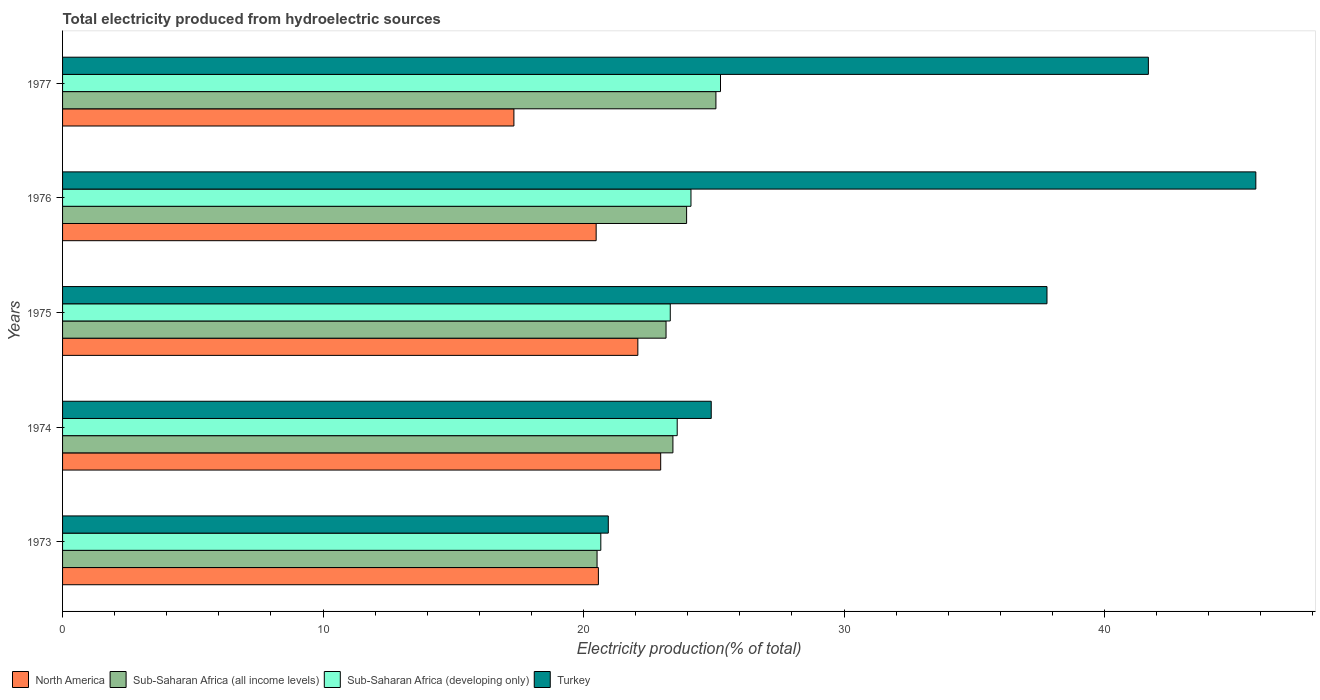How many different coloured bars are there?
Provide a short and direct response. 4. How many groups of bars are there?
Your response must be concise. 5. How many bars are there on the 3rd tick from the top?
Your answer should be compact. 4. How many bars are there on the 4th tick from the bottom?
Offer a very short reply. 4. In how many cases, is the number of bars for a given year not equal to the number of legend labels?
Make the answer very short. 0. What is the total electricity produced in North America in 1975?
Your response must be concise. 22.08. Across all years, what is the maximum total electricity produced in Sub-Saharan Africa (all income levels)?
Provide a short and direct response. 25.08. Across all years, what is the minimum total electricity produced in Turkey?
Offer a very short reply. 20.95. In which year was the total electricity produced in North America maximum?
Make the answer very short. 1974. In which year was the total electricity produced in North America minimum?
Keep it short and to the point. 1977. What is the total total electricity produced in Sub-Saharan Africa (developing only) in the graph?
Your answer should be compact. 116.97. What is the difference between the total electricity produced in Sub-Saharan Africa (all income levels) in 1973 and that in 1975?
Your response must be concise. -2.65. What is the difference between the total electricity produced in Turkey in 1973 and the total electricity produced in Sub-Saharan Africa (developing only) in 1974?
Your answer should be compact. -2.65. What is the average total electricity produced in Turkey per year?
Provide a short and direct response. 34.23. In the year 1977, what is the difference between the total electricity produced in Sub-Saharan Africa (all income levels) and total electricity produced in North America?
Provide a short and direct response. 7.76. In how many years, is the total electricity produced in North America greater than 16 %?
Offer a very short reply. 5. What is the ratio of the total electricity produced in Turkey in 1974 to that in 1976?
Offer a very short reply. 0.54. What is the difference between the highest and the second highest total electricity produced in Sub-Saharan Africa (developing only)?
Give a very brief answer. 1.13. What is the difference between the highest and the lowest total electricity produced in Turkey?
Offer a terse response. 24.86. In how many years, is the total electricity produced in Sub-Saharan Africa (all income levels) greater than the average total electricity produced in Sub-Saharan Africa (all income levels) taken over all years?
Give a very brief answer. 3. What does the 1st bar from the top in 1974 represents?
Give a very brief answer. Turkey. How many bars are there?
Provide a succinct answer. 20. How many years are there in the graph?
Your answer should be compact. 5. What is the difference between two consecutive major ticks on the X-axis?
Make the answer very short. 10. Are the values on the major ticks of X-axis written in scientific E-notation?
Make the answer very short. No. Does the graph contain any zero values?
Keep it short and to the point. No. How many legend labels are there?
Keep it short and to the point. 4. How are the legend labels stacked?
Offer a terse response. Horizontal. What is the title of the graph?
Ensure brevity in your answer.  Total electricity produced from hydroelectric sources. What is the label or title of the Y-axis?
Offer a terse response. Years. What is the Electricity production(% of total) in North America in 1973?
Provide a succinct answer. 20.57. What is the Electricity production(% of total) in Sub-Saharan Africa (all income levels) in 1973?
Offer a terse response. 20.52. What is the Electricity production(% of total) of Sub-Saharan Africa (developing only) in 1973?
Keep it short and to the point. 20.66. What is the Electricity production(% of total) of Turkey in 1973?
Ensure brevity in your answer.  20.95. What is the Electricity production(% of total) in North America in 1974?
Make the answer very short. 22.96. What is the Electricity production(% of total) of Sub-Saharan Africa (all income levels) in 1974?
Provide a short and direct response. 23.43. What is the Electricity production(% of total) of Sub-Saharan Africa (developing only) in 1974?
Your answer should be compact. 23.59. What is the Electricity production(% of total) of Turkey in 1974?
Your response must be concise. 24.9. What is the Electricity production(% of total) of North America in 1975?
Offer a very short reply. 22.08. What is the Electricity production(% of total) in Sub-Saharan Africa (all income levels) in 1975?
Provide a succinct answer. 23.17. What is the Electricity production(% of total) of Sub-Saharan Africa (developing only) in 1975?
Offer a terse response. 23.33. What is the Electricity production(% of total) of Turkey in 1975?
Offer a very short reply. 37.79. What is the Electricity production(% of total) of North America in 1976?
Keep it short and to the point. 20.48. What is the Electricity production(% of total) in Sub-Saharan Africa (all income levels) in 1976?
Offer a terse response. 23.96. What is the Electricity production(% of total) in Sub-Saharan Africa (developing only) in 1976?
Your answer should be compact. 24.12. What is the Electricity production(% of total) in Turkey in 1976?
Your answer should be very brief. 45.81. What is the Electricity production(% of total) in North America in 1977?
Your answer should be very brief. 17.33. What is the Electricity production(% of total) of Sub-Saharan Africa (all income levels) in 1977?
Ensure brevity in your answer.  25.08. What is the Electricity production(% of total) of Sub-Saharan Africa (developing only) in 1977?
Make the answer very short. 25.26. What is the Electricity production(% of total) of Turkey in 1977?
Keep it short and to the point. 41.68. Across all years, what is the maximum Electricity production(% of total) of North America?
Give a very brief answer. 22.96. Across all years, what is the maximum Electricity production(% of total) in Sub-Saharan Africa (all income levels)?
Your response must be concise. 25.08. Across all years, what is the maximum Electricity production(% of total) of Sub-Saharan Africa (developing only)?
Give a very brief answer. 25.26. Across all years, what is the maximum Electricity production(% of total) in Turkey?
Ensure brevity in your answer.  45.81. Across all years, what is the minimum Electricity production(% of total) in North America?
Offer a terse response. 17.33. Across all years, what is the minimum Electricity production(% of total) in Sub-Saharan Africa (all income levels)?
Provide a succinct answer. 20.52. Across all years, what is the minimum Electricity production(% of total) of Sub-Saharan Africa (developing only)?
Your answer should be compact. 20.66. Across all years, what is the minimum Electricity production(% of total) of Turkey?
Offer a terse response. 20.95. What is the total Electricity production(% of total) of North America in the graph?
Keep it short and to the point. 103.42. What is the total Electricity production(% of total) in Sub-Saharan Africa (all income levels) in the graph?
Provide a short and direct response. 116.15. What is the total Electricity production(% of total) of Sub-Saharan Africa (developing only) in the graph?
Offer a terse response. 116.97. What is the total Electricity production(% of total) in Turkey in the graph?
Offer a very short reply. 171.13. What is the difference between the Electricity production(% of total) in North America in 1973 and that in 1974?
Ensure brevity in your answer.  -2.39. What is the difference between the Electricity production(% of total) in Sub-Saharan Africa (all income levels) in 1973 and that in 1974?
Ensure brevity in your answer.  -2.91. What is the difference between the Electricity production(% of total) in Sub-Saharan Africa (developing only) in 1973 and that in 1974?
Your response must be concise. -2.93. What is the difference between the Electricity production(% of total) in Turkey in 1973 and that in 1974?
Make the answer very short. -3.95. What is the difference between the Electricity production(% of total) in North America in 1973 and that in 1975?
Offer a very short reply. -1.51. What is the difference between the Electricity production(% of total) of Sub-Saharan Africa (all income levels) in 1973 and that in 1975?
Make the answer very short. -2.65. What is the difference between the Electricity production(% of total) in Sub-Saharan Africa (developing only) in 1973 and that in 1975?
Keep it short and to the point. -2.67. What is the difference between the Electricity production(% of total) of Turkey in 1973 and that in 1975?
Offer a terse response. -16.84. What is the difference between the Electricity production(% of total) in North America in 1973 and that in 1976?
Offer a terse response. 0.09. What is the difference between the Electricity production(% of total) in Sub-Saharan Africa (all income levels) in 1973 and that in 1976?
Your answer should be compact. -3.44. What is the difference between the Electricity production(% of total) in Sub-Saharan Africa (developing only) in 1973 and that in 1976?
Offer a terse response. -3.46. What is the difference between the Electricity production(% of total) of Turkey in 1973 and that in 1976?
Provide a short and direct response. -24.86. What is the difference between the Electricity production(% of total) of North America in 1973 and that in 1977?
Offer a terse response. 3.24. What is the difference between the Electricity production(% of total) of Sub-Saharan Africa (all income levels) in 1973 and that in 1977?
Your answer should be very brief. -4.56. What is the difference between the Electricity production(% of total) in Sub-Saharan Africa (developing only) in 1973 and that in 1977?
Offer a very short reply. -4.59. What is the difference between the Electricity production(% of total) in Turkey in 1973 and that in 1977?
Provide a short and direct response. -20.73. What is the difference between the Electricity production(% of total) of North America in 1974 and that in 1975?
Ensure brevity in your answer.  0.88. What is the difference between the Electricity production(% of total) in Sub-Saharan Africa (all income levels) in 1974 and that in 1975?
Keep it short and to the point. 0.26. What is the difference between the Electricity production(% of total) in Sub-Saharan Africa (developing only) in 1974 and that in 1975?
Your answer should be very brief. 0.27. What is the difference between the Electricity production(% of total) in Turkey in 1974 and that in 1975?
Keep it short and to the point. -12.89. What is the difference between the Electricity production(% of total) in North America in 1974 and that in 1976?
Your answer should be compact. 2.48. What is the difference between the Electricity production(% of total) of Sub-Saharan Africa (all income levels) in 1974 and that in 1976?
Keep it short and to the point. -0.53. What is the difference between the Electricity production(% of total) of Sub-Saharan Africa (developing only) in 1974 and that in 1976?
Offer a very short reply. -0.53. What is the difference between the Electricity production(% of total) of Turkey in 1974 and that in 1976?
Ensure brevity in your answer.  -20.91. What is the difference between the Electricity production(% of total) of North America in 1974 and that in 1977?
Offer a very short reply. 5.63. What is the difference between the Electricity production(% of total) of Sub-Saharan Africa (all income levels) in 1974 and that in 1977?
Offer a very short reply. -1.65. What is the difference between the Electricity production(% of total) of Sub-Saharan Africa (developing only) in 1974 and that in 1977?
Offer a very short reply. -1.66. What is the difference between the Electricity production(% of total) of Turkey in 1974 and that in 1977?
Provide a short and direct response. -16.78. What is the difference between the Electricity production(% of total) in North America in 1975 and that in 1976?
Make the answer very short. 1.6. What is the difference between the Electricity production(% of total) of Sub-Saharan Africa (all income levels) in 1975 and that in 1976?
Ensure brevity in your answer.  -0.79. What is the difference between the Electricity production(% of total) in Sub-Saharan Africa (developing only) in 1975 and that in 1976?
Offer a terse response. -0.79. What is the difference between the Electricity production(% of total) of Turkey in 1975 and that in 1976?
Offer a terse response. -8.02. What is the difference between the Electricity production(% of total) of North America in 1975 and that in 1977?
Provide a succinct answer. 4.76. What is the difference between the Electricity production(% of total) in Sub-Saharan Africa (all income levels) in 1975 and that in 1977?
Give a very brief answer. -1.91. What is the difference between the Electricity production(% of total) in Sub-Saharan Africa (developing only) in 1975 and that in 1977?
Provide a short and direct response. -1.93. What is the difference between the Electricity production(% of total) in Turkey in 1975 and that in 1977?
Your answer should be very brief. -3.89. What is the difference between the Electricity production(% of total) in North America in 1976 and that in 1977?
Give a very brief answer. 3.16. What is the difference between the Electricity production(% of total) of Sub-Saharan Africa (all income levels) in 1976 and that in 1977?
Your response must be concise. -1.13. What is the difference between the Electricity production(% of total) of Sub-Saharan Africa (developing only) in 1976 and that in 1977?
Provide a succinct answer. -1.13. What is the difference between the Electricity production(% of total) in Turkey in 1976 and that in 1977?
Your answer should be very brief. 4.13. What is the difference between the Electricity production(% of total) in North America in 1973 and the Electricity production(% of total) in Sub-Saharan Africa (all income levels) in 1974?
Keep it short and to the point. -2.86. What is the difference between the Electricity production(% of total) of North America in 1973 and the Electricity production(% of total) of Sub-Saharan Africa (developing only) in 1974?
Ensure brevity in your answer.  -3.03. What is the difference between the Electricity production(% of total) in North America in 1973 and the Electricity production(% of total) in Turkey in 1974?
Provide a short and direct response. -4.33. What is the difference between the Electricity production(% of total) of Sub-Saharan Africa (all income levels) in 1973 and the Electricity production(% of total) of Sub-Saharan Africa (developing only) in 1974?
Offer a terse response. -3.08. What is the difference between the Electricity production(% of total) of Sub-Saharan Africa (all income levels) in 1973 and the Electricity production(% of total) of Turkey in 1974?
Ensure brevity in your answer.  -4.38. What is the difference between the Electricity production(% of total) of Sub-Saharan Africa (developing only) in 1973 and the Electricity production(% of total) of Turkey in 1974?
Keep it short and to the point. -4.24. What is the difference between the Electricity production(% of total) of North America in 1973 and the Electricity production(% of total) of Sub-Saharan Africa (all income levels) in 1975?
Offer a very short reply. -2.6. What is the difference between the Electricity production(% of total) of North America in 1973 and the Electricity production(% of total) of Sub-Saharan Africa (developing only) in 1975?
Keep it short and to the point. -2.76. What is the difference between the Electricity production(% of total) of North America in 1973 and the Electricity production(% of total) of Turkey in 1975?
Ensure brevity in your answer.  -17.22. What is the difference between the Electricity production(% of total) of Sub-Saharan Africa (all income levels) in 1973 and the Electricity production(% of total) of Sub-Saharan Africa (developing only) in 1975?
Provide a succinct answer. -2.81. What is the difference between the Electricity production(% of total) in Sub-Saharan Africa (all income levels) in 1973 and the Electricity production(% of total) in Turkey in 1975?
Offer a terse response. -17.27. What is the difference between the Electricity production(% of total) of Sub-Saharan Africa (developing only) in 1973 and the Electricity production(% of total) of Turkey in 1975?
Your response must be concise. -17.13. What is the difference between the Electricity production(% of total) of North America in 1973 and the Electricity production(% of total) of Sub-Saharan Africa (all income levels) in 1976?
Ensure brevity in your answer.  -3.39. What is the difference between the Electricity production(% of total) of North America in 1973 and the Electricity production(% of total) of Sub-Saharan Africa (developing only) in 1976?
Give a very brief answer. -3.55. What is the difference between the Electricity production(% of total) in North America in 1973 and the Electricity production(% of total) in Turkey in 1976?
Offer a terse response. -25.24. What is the difference between the Electricity production(% of total) of Sub-Saharan Africa (all income levels) in 1973 and the Electricity production(% of total) of Sub-Saharan Africa (developing only) in 1976?
Your answer should be very brief. -3.6. What is the difference between the Electricity production(% of total) of Sub-Saharan Africa (all income levels) in 1973 and the Electricity production(% of total) of Turkey in 1976?
Provide a short and direct response. -25.29. What is the difference between the Electricity production(% of total) of Sub-Saharan Africa (developing only) in 1973 and the Electricity production(% of total) of Turkey in 1976?
Make the answer very short. -25.15. What is the difference between the Electricity production(% of total) of North America in 1973 and the Electricity production(% of total) of Sub-Saharan Africa (all income levels) in 1977?
Keep it short and to the point. -4.51. What is the difference between the Electricity production(% of total) in North America in 1973 and the Electricity production(% of total) in Sub-Saharan Africa (developing only) in 1977?
Your response must be concise. -4.69. What is the difference between the Electricity production(% of total) of North America in 1973 and the Electricity production(% of total) of Turkey in 1977?
Provide a short and direct response. -21.11. What is the difference between the Electricity production(% of total) in Sub-Saharan Africa (all income levels) in 1973 and the Electricity production(% of total) in Sub-Saharan Africa (developing only) in 1977?
Your answer should be compact. -4.74. What is the difference between the Electricity production(% of total) in Sub-Saharan Africa (all income levels) in 1973 and the Electricity production(% of total) in Turkey in 1977?
Provide a short and direct response. -21.16. What is the difference between the Electricity production(% of total) in Sub-Saharan Africa (developing only) in 1973 and the Electricity production(% of total) in Turkey in 1977?
Provide a short and direct response. -21.02. What is the difference between the Electricity production(% of total) of North America in 1974 and the Electricity production(% of total) of Sub-Saharan Africa (all income levels) in 1975?
Provide a short and direct response. -0.21. What is the difference between the Electricity production(% of total) in North America in 1974 and the Electricity production(% of total) in Sub-Saharan Africa (developing only) in 1975?
Give a very brief answer. -0.37. What is the difference between the Electricity production(% of total) of North America in 1974 and the Electricity production(% of total) of Turkey in 1975?
Keep it short and to the point. -14.83. What is the difference between the Electricity production(% of total) in Sub-Saharan Africa (all income levels) in 1974 and the Electricity production(% of total) in Sub-Saharan Africa (developing only) in 1975?
Give a very brief answer. 0.1. What is the difference between the Electricity production(% of total) in Sub-Saharan Africa (all income levels) in 1974 and the Electricity production(% of total) in Turkey in 1975?
Ensure brevity in your answer.  -14.36. What is the difference between the Electricity production(% of total) of Sub-Saharan Africa (developing only) in 1974 and the Electricity production(% of total) of Turkey in 1975?
Ensure brevity in your answer.  -14.2. What is the difference between the Electricity production(% of total) of North America in 1974 and the Electricity production(% of total) of Sub-Saharan Africa (all income levels) in 1976?
Your response must be concise. -0.99. What is the difference between the Electricity production(% of total) of North America in 1974 and the Electricity production(% of total) of Sub-Saharan Africa (developing only) in 1976?
Give a very brief answer. -1.16. What is the difference between the Electricity production(% of total) of North America in 1974 and the Electricity production(% of total) of Turkey in 1976?
Provide a succinct answer. -22.85. What is the difference between the Electricity production(% of total) of Sub-Saharan Africa (all income levels) in 1974 and the Electricity production(% of total) of Sub-Saharan Africa (developing only) in 1976?
Ensure brevity in your answer.  -0.69. What is the difference between the Electricity production(% of total) in Sub-Saharan Africa (all income levels) in 1974 and the Electricity production(% of total) in Turkey in 1976?
Offer a terse response. -22.38. What is the difference between the Electricity production(% of total) of Sub-Saharan Africa (developing only) in 1974 and the Electricity production(% of total) of Turkey in 1976?
Provide a short and direct response. -22.21. What is the difference between the Electricity production(% of total) in North America in 1974 and the Electricity production(% of total) in Sub-Saharan Africa (all income levels) in 1977?
Your response must be concise. -2.12. What is the difference between the Electricity production(% of total) in North America in 1974 and the Electricity production(% of total) in Sub-Saharan Africa (developing only) in 1977?
Provide a succinct answer. -2.3. What is the difference between the Electricity production(% of total) of North America in 1974 and the Electricity production(% of total) of Turkey in 1977?
Ensure brevity in your answer.  -18.72. What is the difference between the Electricity production(% of total) in Sub-Saharan Africa (all income levels) in 1974 and the Electricity production(% of total) in Sub-Saharan Africa (developing only) in 1977?
Offer a terse response. -1.83. What is the difference between the Electricity production(% of total) in Sub-Saharan Africa (all income levels) in 1974 and the Electricity production(% of total) in Turkey in 1977?
Your answer should be compact. -18.25. What is the difference between the Electricity production(% of total) of Sub-Saharan Africa (developing only) in 1974 and the Electricity production(% of total) of Turkey in 1977?
Your answer should be compact. -18.09. What is the difference between the Electricity production(% of total) of North America in 1975 and the Electricity production(% of total) of Sub-Saharan Africa (all income levels) in 1976?
Your response must be concise. -1.87. What is the difference between the Electricity production(% of total) of North America in 1975 and the Electricity production(% of total) of Sub-Saharan Africa (developing only) in 1976?
Ensure brevity in your answer.  -2.04. What is the difference between the Electricity production(% of total) in North America in 1975 and the Electricity production(% of total) in Turkey in 1976?
Offer a very short reply. -23.72. What is the difference between the Electricity production(% of total) of Sub-Saharan Africa (all income levels) in 1975 and the Electricity production(% of total) of Sub-Saharan Africa (developing only) in 1976?
Provide a succinct answer. -0.96. What is the difference between the Electricity production(% of total) of Sub-Saharan Africa (all income levels) in 1975 and the Electricity production(% of total) of Turkey in 1976?
Give a very brief answer. -22.64. What is the difference between the Electricity production(% of total) of Sub-Saharan Africa (developing only) in 1975 and the Electricity production(% of total) of Turkey in 1976?
Offer a terse response. -22.48. What is the difference between the Electricity production(% of total) in North America in 1975 and the Electricity production(% of total) in Sub-Saharan Africa (all income levels) in 1977?
Your answer should be very brief. -3. What is the difference between the Electricity production(% of total) in North America in 1975 and the Electricity production(% of total) in Sub-Saharan Africa (developing only) in 1977?
Ensure brevity in your answer.  -3.17. What is the difference between the Electricity production(% of total) in North America in 1975 and the Electricity production(% of total) in Turkey in 1977?
Make the answer very short. -19.6. What is the difference between the Electricity production(% of total) of Sub-Saharan Africa (all income levels) in 1975 and the Electricity production(% of total) of Sub-Saharan Africa (developing only) in 1977?
Make the answer very short. -2.09. What is the difference between the Electricity production(% of total) of Sub-Saharan Africa (all income levels) in 1975 and the Electricity production(% of total) of Turkey in 1977?
Your response must be concise. -18.52. What is the difference between the Electricity production(% of total) of Sub-Saharan Africa (developing only) in 1975 and the Electricity production(% of total) of Turkey in 1977?
Offer a terse response. -18.35. What is the difference between the Electricity production(% of total) of North America in 1976 and the Electricity production(% of total) of Sub-Saharan Africa (all income levels) in 1977?
Offer a very short reply. -4.6. What is the difference between the Electricity production(% of total) in North America in 1976 and the Electricity production(% of total) in Sub-Saharan Africa (developing only) in 1977?
Offer a very short reply. -4.77. What is the difference between the Electricity production(% of total) in North America in 1976 and the Electricity production(% of total) in Turkey in 1977?
Your response must be concise. -21.2. What is the difference between the Electricity production(% of total) in Sub-Saharan Africa (all income levels) in 1976 and the Electricity production(% of total) in Sub-Saharan Africa (developing only) in 1977?
Provide a succinct answer. -1.3. What is the difference between the Electricity production(% of total) of Sub-Saharan Africa (all income levels) in 1976 and the Electricity production(% of total) of Turkey in 1977?
Give a very brief answer. -17.73. What is the difference between the Electricity production(% of total) in Sub-Saharan Africa (developing only) in 1976 and the Electricity production(% of total) in Turkey in 1977?
Ensure brevity in your answer.  -17.56. What is the average Electricity production(% of total) of North America per year?
Your answer should be compact. 20.68. What is the average Electricity production(% of total) of Sub-Saharan Africa (all income levels) per year?
Provide a short and direct response. 23.23. What is the average Electricity production(% of total) of Sub-Saharan Africa (developing only) per year?
Offer a very short reply. 23.39. What is the average Electricity production(% of total) in Turkey per year?
Offer a very short reply. 34.23. In the year 1973, what is the difference between the Electricity production(% of total) in North America and Electricity production(% of total) in Sub-Saharan Africa (all income levels)?
Provide a succinct answer. 0.05. In the year 1973, what is the difference between the Electricity production(% of total) of North America and Electricity production(% of total) of Sub-Saharan Africa (developing only)?
Your answer should be very brief. -0.09. In the year 1973, what is the difference between the Electricity production(% of total) in North America and Electricity production(% of total) in Turkey?
Provide a succinct answer. -0.38. In the year 1973, what is the difference between the Electricity production(% of total) in Sub-Saharan Africa (all income levels) and Electricity production(% of total) in Sub-Saharan Africa (developing only)?
Your answer should be compact. -0.14. In the year 1973, what is the difference between the Electricity production(% of total) in Sub-Saharan Africa (all income levels) and Electricity production(% of total) in Turkey?
Offer a very short reply. -0.43. In the year 1973, what is the difference between the Electricity production(% of total) of Sub-Saharan Africa (developing only) and Electricity production(% of total) of Turkey?
Provide a succinct answer. -0.29. In the year 1974, what is the difference between the Electricity production(% of total) in North America and Electricity production(% of total) in Sub-Saharan Africa (all income levels)?
Ensure brevity in your answer.  -0.47. In the year 1974, what is the difference between the Electricity production(% of total) in North America and Electricity production(% of total) in Sub-Saharan Africa (developing only)?
Ensure brevity in your answer.  -0.63. In the year 1974, what is the difference between the Electricity production(% of total) in North America and Electricity production(% of total) in Turkey?
Your answer should be compact. -1.94. In the year 1974, what is the difference between the Electricity production(% of total) in Sub-Saharan Africa (all income levels) and Electricity production(% of total) in Sub-Saharan Africa (developing only)?
Your answer should be compact. -0.16. In the year 1974, what is the difference between the Electricity production(% of total) in Sub-Saharan Africa (all income levels) and Electricity production(% of total) in Turkey?
Ensure brevity in your answer.  -1.47. In the year 1974, what is the difference between the Electricity production(% of total) of Sub-Saharan Africa (developing only) and Electricity production(% of total) of Turkey?
Offer a very short reply. -1.31. In the year 1975, what is the difference between the Electricity production(% of total) of North America and Electricity production(% of total) of Sub-Saharan Africa (all income levels)?
Offer a very short reply. -1.08. In the year 1975, what is the difference between the Electricity production(% of total) of North America and Electricity production(% of total) of Sub-Saharan Africa (developing only)?
Your response must be concise. -1.25. In the year 1975, what is the difference between the Electricity production(% of total) in North America and Electricity production(% of total) in Turkey?
Ensure brevity in your answer.  -15.71. In the year 1975, what is the difference between the Electricity production(% of total) in Sub-Saharan Africa (all income levels) and Electricity production(% of total) in Sub-Saharan Africa (developing only)?
Ensure brevity in your answer.  -0.16. In the year 1975, what is the difference between the Electricity production(% of total) in Sub-Saharan Africa (all income levels) and Electricity production(% of total) in Turkey?
Offer a very short reply. -14.62. In the year 1975, what is the difference between the Electricity production(% of total) in Sub-Saharan Africa (developing only) and Electricity production(% of total) in Turkey?
Your answer should be compact. -14.46. In the year 1976, what is the difference between the Electricity production(% of total) of North America and Electricity production(% of total) of Sub-Saharan Africa (all income levels)?
Offer a very short reply. -3.47. In the year 1976, what is the difference between the Electricity production(% of total) of North America and Electricity production(% of total) of Sub-Saharan Africa (developing only)?
Your response must be concise. -3.64. In the year 1976, what is the difference between the Electricity production(% of total) of North America and Electricity production(% of total) of Turkey?
Offer a very short reply. -25.32. In the year 1976, what is the difference between the Electricity production(% of total) of Sub-Saharan Africa (all income levels) and Electricity production(% of total) of Sub-Saharan Africa (developing only)?
Give a very brief answer. -0.17. In the year 1976, what is the difference between the Electricity production(% of total) in Sub-Saharan Africa (all income levels) and Electricity production(% of total) in Turkey?
Your answer should be very brief. -21.85. In the year 1976, what is the difference between the Electricity production(% of total) of Sub-Saharan Africa (developing only) and Electricity production(% of total) of Turkey?
Provide a succinct answer. -21.68. In the year 1977, what is the difference between the Electricity production(% of total) of North America and Electricity production(% of total) of Sub-Saharan Africa (all income levels)?
Keep it short and to the point. -7.75. In the year 1977, what is the difference between the Electricity production(% of total) in North America and Electricity production(% of total) in Sub-Saharan Africa (developing only)?
Offer a very short reply. -7.93. In the year 1977, what is the difference between the Electricity production(% of total) of North America and Electricity production(% of total) of Turkey?
Your answer should be very brief. -24.36. In the year 1977, what is the difference between the Electricity production(% of total) of Sub-Saharan Africa (all income levels) and Electricity production(% of total) of Sub-Saharan Africa (developing only)?
Make the answer very short. -0.18. In the year 1977, what is the difference between the Electricity production(% of total) of Sub-Saharan Africa (all income levels) and Electricity production(% of total) of Turkey?
Give a very brief answer. -16.6. In the year 1977, what is the difference between the Electricity production(% of total) in Sub-Saharan Africa (developing only) and Electricity production(% of total) in Turkey?
Your response must be concise. -16.43. What is the ratio of the Electricity production(% of total) in North America in 1973 to that in 1974?
Offer a very short reply. 0.9. What is the ratio of the Electricity production(% of total) of Sub-Saharan Africa (all income levels) in 1973 to that in 1974?
Your answer should be very brief. 0.88. What is the ratio of the Electricity production(% of total) of Sub-Saharan Africa (developing only) in 1973 to that in 1974?
Your answer should be compact. 0.88. What is the ratio of the Electricity production(% of total) in Turkey in 1973 to that in 1974?
Your answer should be compact. 0.84. What is the ratio of the Electricity production(% of total) in North America in 1973 to that in 1975?
Offer a very short reply. 0.93. What is the ratio of the Electricity production(% of total) in Sub-Saharan Africa (all income levels) in 1973 to that in 1975?
Keep it short and to the point. 0.89. What is the ratio of the Electricity production(% of total) of Sub-Saharan Africa (developing only) in 1973 to that in 1975?
Offer a terse response. 0.89. What is the ratio of the Electricity production(% of total) in Turkey in 1973 to that in 1975?
Your response must be concise. 0.55. What is the ratio of the Electricity production(% of total) in North America in 1973 to that in 1976?
Ensure brevity in your answer.  1. What is the ratio of the Electricity production(% of total) in Sub-Saharan Africa (all income levels) in 1973 to that in 1976?
Make the answer very short. 0.86. What is the ratio of the Electricity production(% of total) of Sub-Saharan Africa (developing only) in 1973 to that in 1976?
Provide a succinct answer. 0.86. What is the ratio of the Electricity production(% of total) in Turkey in 1973 to that in 1976?
Your response must be concise. 0.46. What is the ratio of the Electricity production(% of total) in North America in 1973 to that in 1977?
Your answer should be very brief. 1.19. What is the ratio of the Electricity production(% of total) in Sub-Saharan Africa (all income levels) in 1973 to that in 1977?
Give a very brief answer. 0.82. What is the ratio of the Electricity production(% of total) in Sub-Saharan Africa (developing only) in 1973 to that in 1977?
Give a very brief answer. 0.82. What is the ratio of the Electricity production(% of total) of Turkey in 1973 to that in 1977?
Your answer should be compact. 0.5. What is the ratio of the Electricity production(% of total) of North America in 1974 to that in 1975?
Your answer should be very brief. 1.04. What is the ratio of the Electricity production(% of total) of Sub-Saharan Africa (all income levels) in 1974 to that in 1975?
Offer a very short reply. 1.01. What is the ratio of the Electricity production(% of total) in Sub-Saharan Africa (developing only) in 1974 to that in 1975?
Offer a very short reply. 1.01. What is the ratio of the Electricity production(% of total) in Turkey in 1974 to that in 1975?
Give a very brief answer. 0.66. What is the ratio of the Electricity production(% of total) of North America in 1974 to that in 1976?
Keep it short and to the point. 1.12. What is the ratio of the Electricity production(% of total) of Sub-Saharan Africa (all income levels) in 1974 to that in 1976?
Provide a short and direct response. 0.98. What is the ratio of the Electricity production(% of total) in Sub-Saharan Africa (developing only) in 1974 to that in 1976?
Provide a succinct answer. 0.98. What is the ratio of the Electricity production(% of total) of Turkey in 1974 to that in 1976?
Offer a terse response. 0.54. What is the ratio of the Electricity production(% of total) in North America in 1974 to that in 1977?
Your answer should be very brief. 1.33. What is the ratio of the Electricity production(% of total) in Sub-Saharan Africa (all income levels) in 1974 to that in 1977?
Provide a short and direct response. 0.93. What is the ratio of the Electricity production(% of total) of Sub-Saharan Africa (developing only) in 1974 to that in 1977?
Make the answer very short. 0.93. What is the ratio of the Electricity production(% of total) in Turkey in 1974 to that in 1977?
Provide a succinct answer. 0.6. What is the ratio of the Electricity production(% of total) of North America in 1975 to that in 1976?
Provide a short and direct response. 1.08. What is the ratio of the Electricity production(% of total) in Sub-Saharan Africa (all income levels) in 1975 to that in 1976?
Give a very brief answer. 0.97. What is the ratio of the Electricity production(% of total) of Sub-Saharan Africa (developing only) in 1975 to that in 1976?
Offer a terse response. 0.97. What is the ratio of the Electricity production(% of total) of Turkey in 1975 to that in 1976?
Offer a terse response. 0.82. What is the ratio of the Electricity production(% of total) of North America in 1975 to that in 1977?
Your response must be concise. 1.27. What is the ratio of the Electricity production(% of total) in Sub-Saharan Africa (all income levels) in 1975 to that in 1977?
Offer a terse response. 0.92. What is the ratio of the Electricity production(% of total) of Sub-Saharan Africa (developing only) in 1975 to that in 1977?
Offer a very short reply. 0.92. What is the ratio of the Electricity production(% of total) of Turkey in 1975 to that in 1977?
Ensure brevity in your answer.  0.91. What is the ratio of the Electricity production(% of total) of North America in 1976 to that in 1977?
Ensure brevity in your answer.  1.18. What is the ratio of the Electricity production(% of total) in Sub-Saharan Africa (all income levels) in 1976 to that in 1977?
Provide a short and direct response. 0.96. What is the ratio of the Electricity production(% of total) of Sub-Saharan Africa (developing only) in 1976 to that in 1977?
Your answer should be very brief. 0.96. What is the ratio of the Electricity production(% of total) of Turkey in 1976 to that in 1977?
Keep it short and to the point. 1.1. What is the difference between the highest and the second highest Electricity production(% of total) in North America?
Provide a succinct answer. 0.88. What is the difference between the highest and the second highest Electricity production(% of total) in Sub-Saharan Africa (all income levels)?
Ensure brevity in your answer.  1.13. What is the difference between the highest and the second highest Electricity production(% of total) of Sub-Saharan Africa (developing only)?
Provide a succinct answer. 1.13. What is the difference between the highest and the second highest Electricity production(% of total) of Turkey?
Keep it short and to the point. 4.13. What is the difference between the highest and the lowest Electricity production(% of total) in North America?
Provide a short and direct response. 5.63. What is the difference between the highest and the lowest Electricity production(% of total) of Sub-Saharan Africa (all income levels)?
Provide a short and direct response. 4.56. What is the difference between the highest and the lowest Electricity production(% of total) in Sub-Saharan Africa (developing only)?
Make the answer very short. 4.59. What is the difference between the highest and the lowest Electricity production(% of total) in Turkey?
Keep it short and to the point. 24.86. 